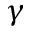<formula> <loc_0><loc_0><loc_500><loc_500>\gamma</formula> 